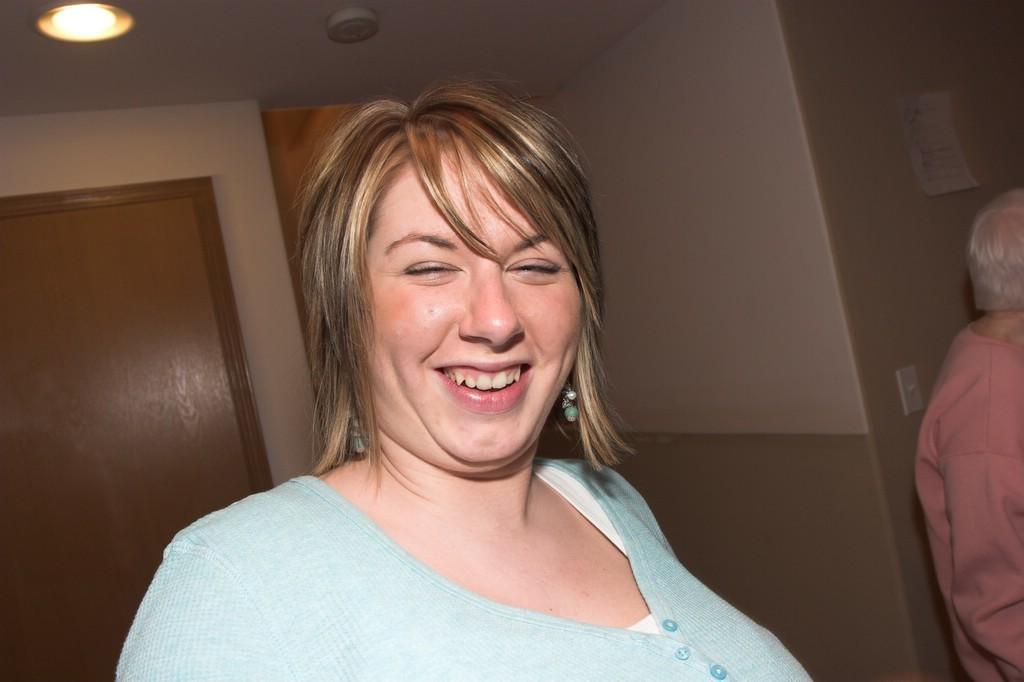Who is present in the image? There is a woman and another person in the image. What is the woman doing in the image? The woman is smiling in the image. What can be seen in the background of the image? There is a wall, a door, and lights on the ceiling in the background of the image. What type of eggs are being cooked in the image? There are no eggs present in the image. How much payment is being exchanged in the image? There is no payment being exchanged in the image. 